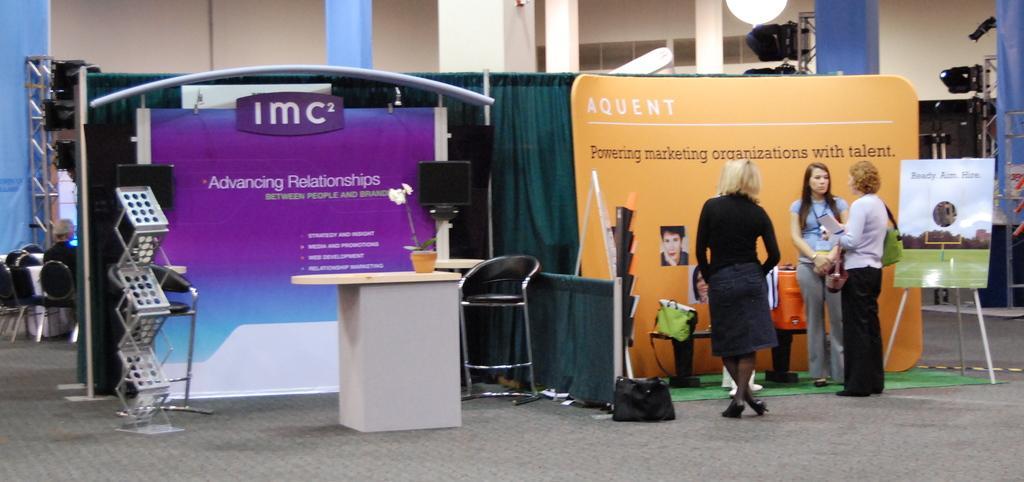Describe this image in one or two sentences. In this image I can see 3 women standing on the right. There are chairs and banners. There is a plant pot on a table. There are green curtains and chairs at the back. A person is sitting at the back. There are pillars. 